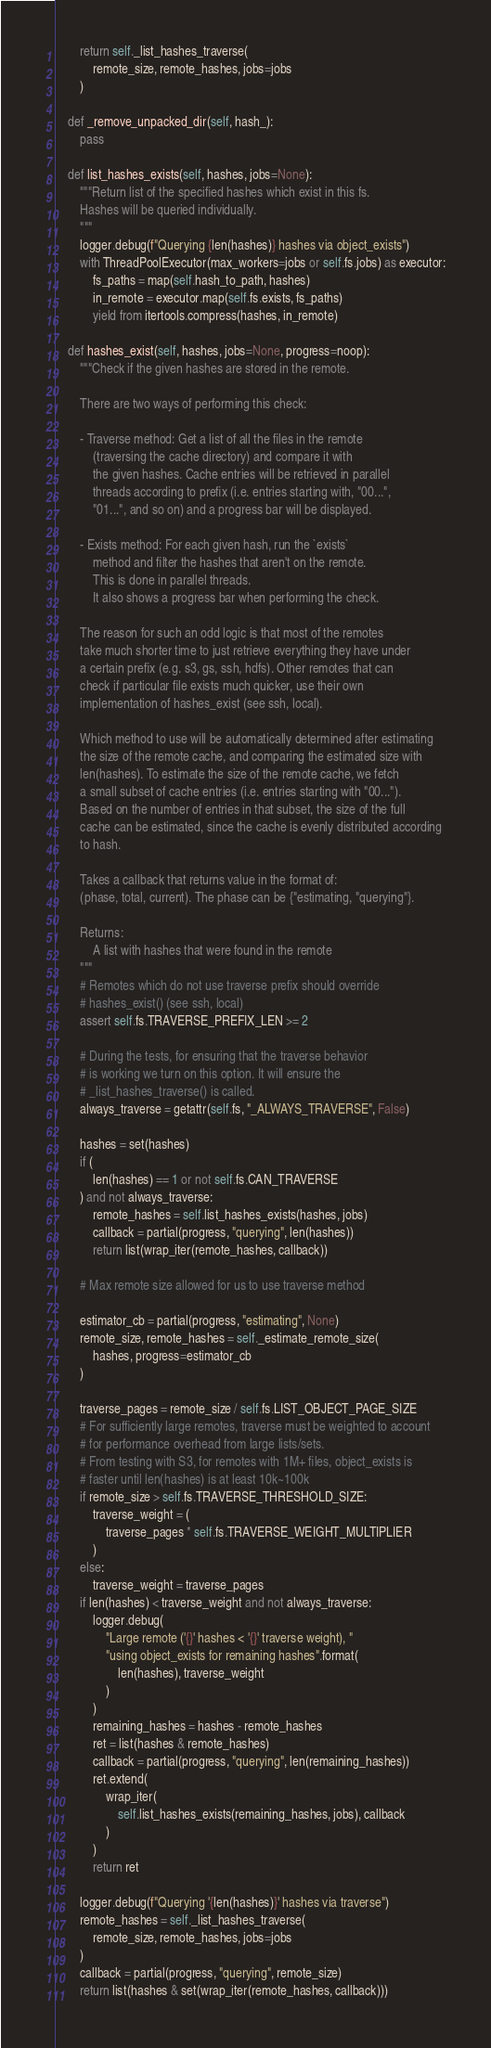<code> <loc_0><loc_0><loc_500><loc_500><_Python_>        return self._list_hashes_traverse(
            remote_size, remote_hashes, jobs=jobs
        )

    def _remove_unpacked_dir(self, hash_):
        pass

    def list_hashes_exists(self, hashes, jobs=None):
        """Return list of the specified hashes which exist in this fs.
        Hashes will be queried individually.
        """
        logger.debug(f"Querying {len(hashes)} hashes via object_exists")
        with ThreadPoolExecutor(max_workers=jobs or self.fs.jobs) as executor:
            fs_paths = map(self.hash_to_path, hashes)
            in_remote = executor.map(self.fs.exists, fs_paths)
            yield from itertools.compress(hashes, in_remote)

    def hashes_exist(self, hashes, jobs=None, progress=noop):
        """Check if the given hashes are stored in the remote.

        There are two ways of performing this check:

        - Traverse method: Get a list of all the files in the remote
            (traversing the cache directory) and compare it with
            the given hashes. Cache entries will be retrieved in parallel
            threads according to prefix (i.e. entries starting with, "00...",
            "01...", and so on) and a progress bar will be displayed.

        - Exists method: For each given hash, run the `exists`
            method and filter the hashes that aren't on the remote.
            This is done in parallel threads.
            It also shows a progress bar when performing the check.

        The reason for such an odd logic is that most of the remotes
        take much shorter time to just retrieve everything they have under
        a certain prefix (e.g. s3, gs, ssh, hdfs). Other remotes that can
        check if particular file exists much quicker, use their own
        implementation of hashes_exist (see ssh, local).

        Which method to use will be automatically determined after estimating
        the size of the remote cache, and comparing the estimated size with
        len(hashes). To estimate the size of the remote cache, we fetch
        a small subset of cache entries (i.e. entries starting with "00...").
        Based on the number of entries in that subset, the size of the full
        cache can be estimated, since the cache is evenly distributed according
        to hash.

        Takes a callback that returns value in the format of:
        (phase, total, current). The phase can be {"estimating, "querying"}.

        Returns:
            A list with hashes that were found in the remote
        """
        # Remotes which do not use traverse prefix should override
        # hashes_exist() (see ssh, local)
        assert self.fs.TRAVERSE_PREFIX_LEN >= 2

        # During the tests, for ensuring that the traverse behavior
        # is working we turn on this option. It will ensure the
        # _list_hashes_traverse() is called.
        always_traverse = getattr(self.fs, "_ALWAYS_TRAVERSE", False)

        hashes = set(hashes)
        if (
            len(hashes) == 1 or not self.fs.CAN_TRAVERSE
        ) and not always_traverse:
            remote_hashes = self.list_hashes_exists(hashes, jobs)
            callback = partial(progress, "querying", len(hashes))
            return list(wrap_iter(remote_hashes, callback))

        # Max remote size allowed for us to use traverse method

        estimator_cb = partial(progress, "estimating", None)
        remote_size, remote_hashes = self._estimate_remote_size(
            hashes, progress=estimator_cb
        )

        traverse_pages = remote_size / self.fs.LIST_OBJECT_PAGE_SIZE
        # For sufficiently large remotes, traverse must be weighted to account
        # for performance overhead from large lists/sets.
        # From testing with S3, for remotes with 1M+ files, object_exists is
        # faster until len(hashes) is at least 10k~100k
        if remote_size > self.fs.TRAVERSE_THRESHOLD_SIZE:
            traverse_weight = (
                traverse_pages * self.fs.TRAVERSE_WEIGHT_MULTIPLIER
            )
        else:
            traverse_weight = traverse_pages
        if len(hashes) < traverse_weight and not always_traverse:
            logger.debug(
                "Large remote ('{}' hashes < '{}' traverse weight), "
                "using object_exists for remaining hashes".format(
                    len(hashes), traverse_weight
                )
            )
            remaining_hashes = hashes - remote_hashes
            ret = list(hashes & remote_hashes)
            callback = partial(progress, "querying", len(remaining_hashes))
            ret.extend(
                wrap_iter(
                    self.list_hashes_exists(remaining_hashes, jobs), callback
                )
            )
            return ret

        logger.debug(f"Querying '{len(hashes)}' hashes via traverse")
        remote_hashes = self._list_hashes_traverse(
            remote_size, remote_hashes, jobs=jobs
        )
        callback = partial(progress, "querying", remote_size)
        return list(hashes & set(wrap_iter(remote_hashes, callback)))
</code> 